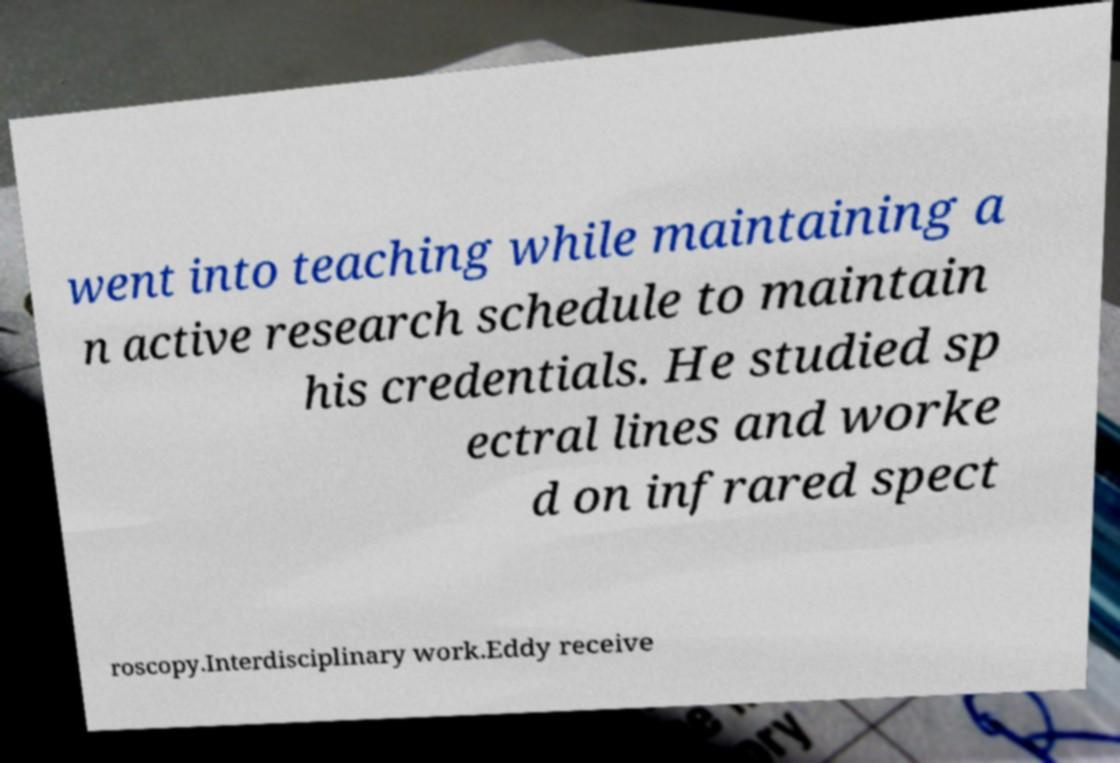For documentation purposes, I need the text within this image transcribed. Could you provide that? went into teaching while maintaining a n active research schedule to maintain his credentials. He studied sp ectral lines and worke d on infrared spect roscopy.Interdisciplinary work.Eddy receive 